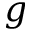<formula> <loc_0><loc_0><loc_500><loc_500>g</formula> 